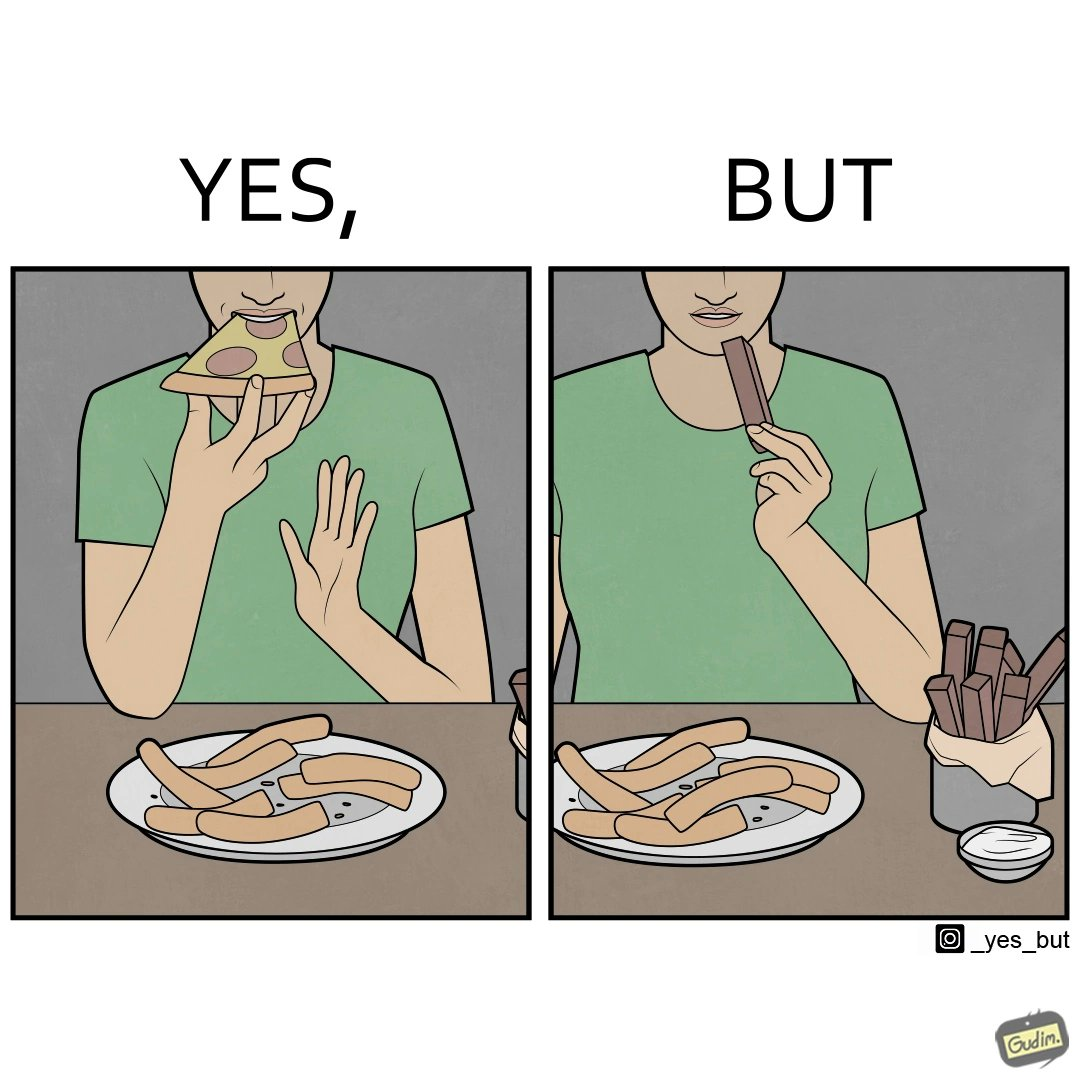Describe the satirical element in this image. the irony in this image is that people waste pizza crust by saying that it is too hard, while they eat hard chocolate without any complaints 